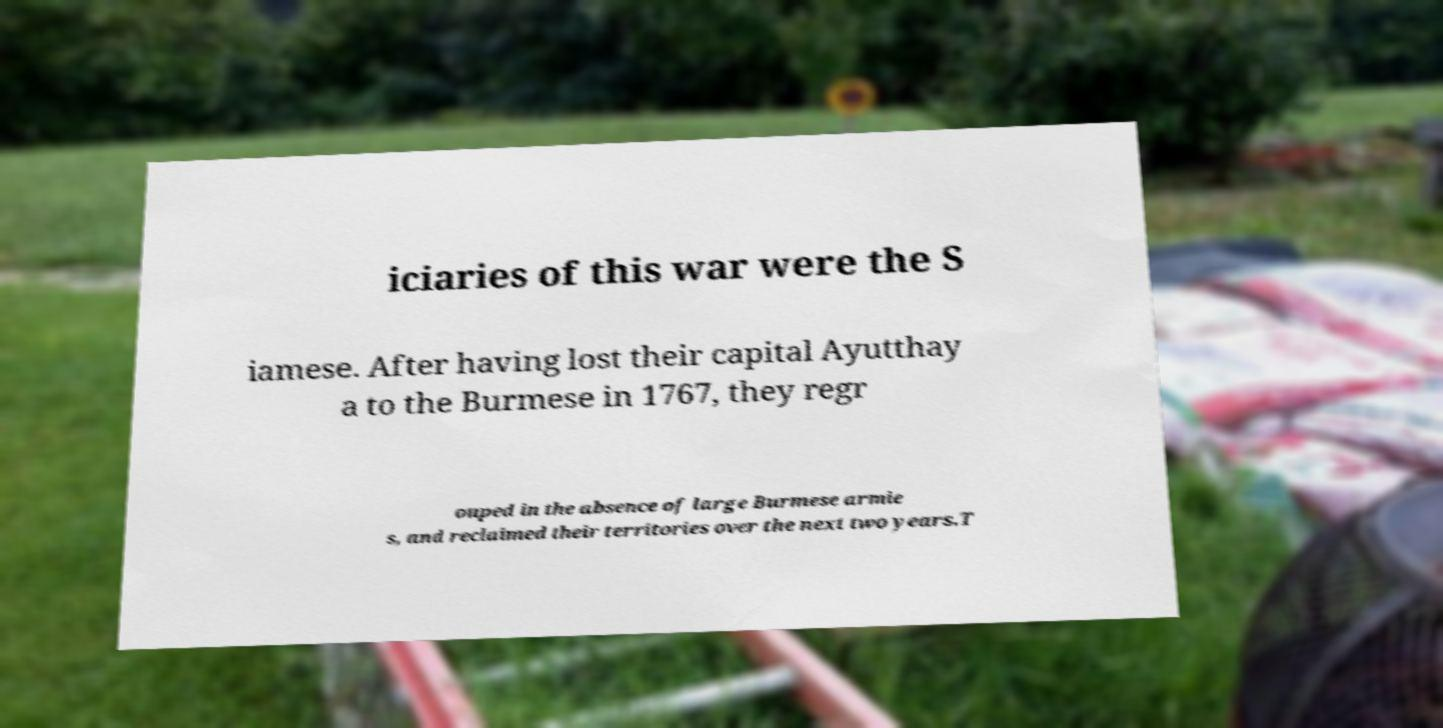Could you assist in decoding the text presented in this image and type it out clearly? iciaries of this war were the S iamese. After having lost their capital Ayutthay a to the Burmese in 1767, they regr ouped in the absence of large Burmese armie s, and reclaimed their territories over the next two years.T 